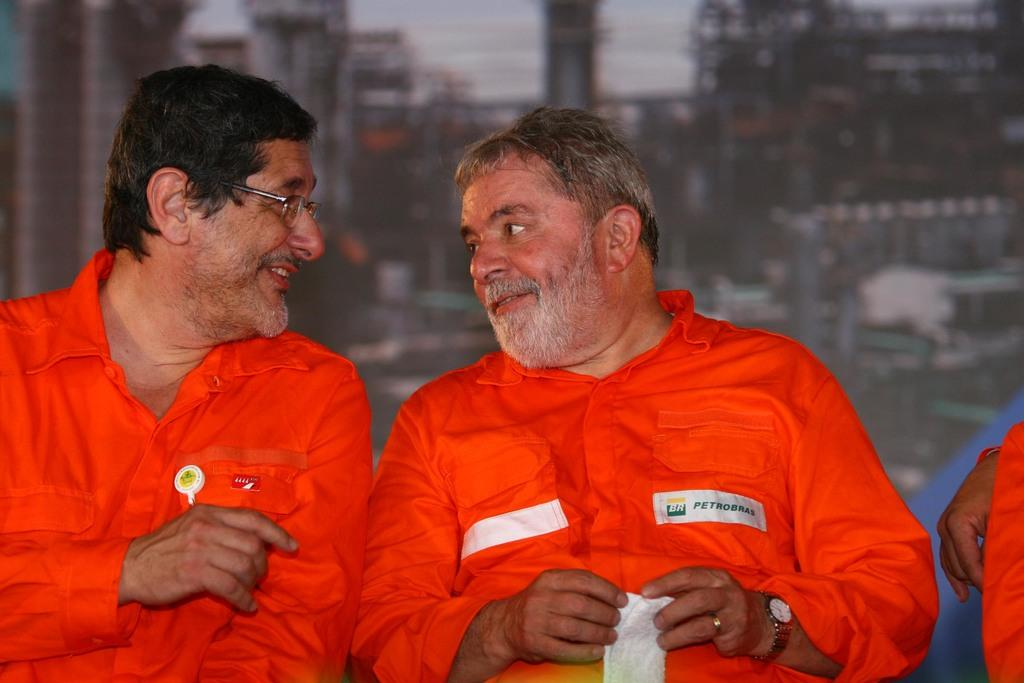How many people are present in the image? There are three people in the image. What are the people wearing? The people are wearing orange color shirts. What can be seen in the background of the image? The background includes buildings. How is the background depicted in the image? The background is blurred. Can you tell me what type of amusement is present in the image? There is no amusement present in the image; it features three people wearing orange shirts in front of a blurred background with buildings. What kind of organization is depicted in the image? There is no organization depicted in the image; it simply shows three people and a background with buildings. 